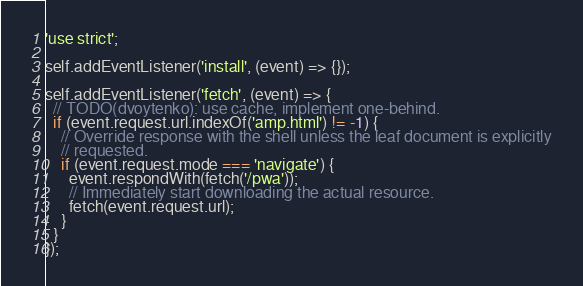Convert code to text. <code><loc_0><loc_0><loc_500><loc_500><_JavaScript_>'use strict';

self.addEventListener('install', (event) => {});

self.addEventListener('fetch', (event) => {
  // TODO(dvoytenko): use cache, implement one-behind.
  if (event.request.url.indexOf('amp.html') != -1) {
    // Override response with the shell unless the leaf document is explicitly
    // requested.
    if (event.request.mode === 'navigate') {
      event.respondWith(fetch('/pwa'));
      // Immediately start downloading the actual resource.
      fetch(event.request.url);
    }
  }
});
</code> 